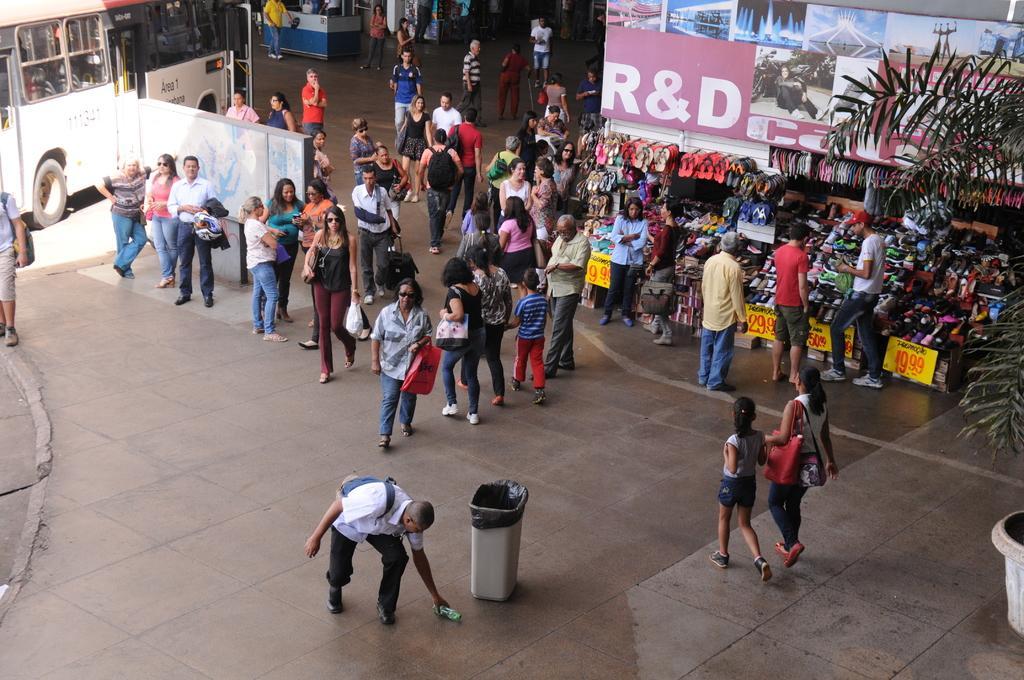In one or two sentences, can you explain what this image depicts? In this picture we can see a group of people on the floor, dustbin, bags, posters, plant, footwear, bus and some objects. 